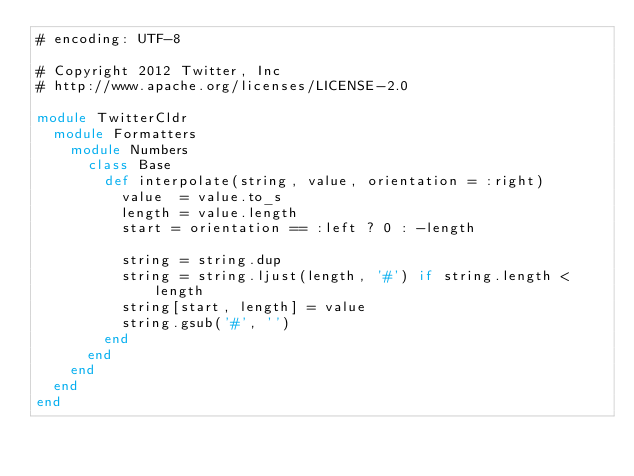<code> <loc_0><loc_0><loc_500><loc_500><_Ruby_># encoding: UTF-8

# Copyright 2012 Twitter, Inc
# http://www.apache.org/licenses/LICENSE-2.0

module TwitterCldr
  module Formatters
    module Numbers
      class Base
        def interpolate(string, value, orientation = :right)
          value  = value.to_s
          length = value.length
          start = orientation == :left ? 0 : -length

          string = string.dup
          string = string.ljust(length, '#') if string.length < length
          string[start, length] = value
          string.gsub('#', '')
        end
      end
    end
  end
end</code> 